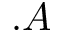Convert formula to latex. <formula><loc_0><loc_0><loc_500><loc_500>. A</formula> 